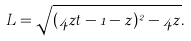<formula> <loc_0><loc_0><loc_500><loc_500>L = \sqrt { ( 4 z t - 1 - z ) ^ { 2 } - 4 z } .</formula> 